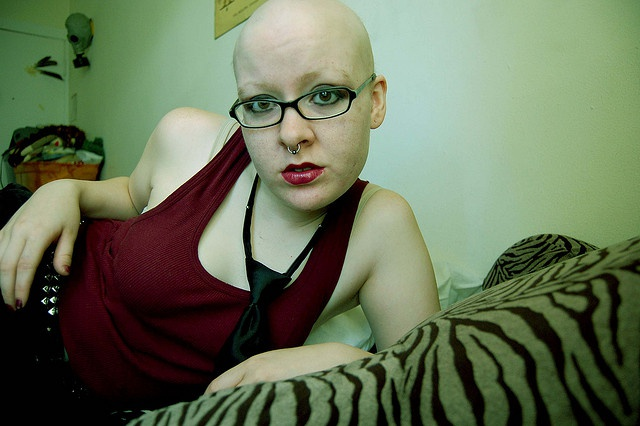Describe the objects in this image and their specific colors. I can see people in darkgreen, black, darkgray, olive, and maroon tones, bed in darkgreen, black, and green tones, and tie in darkgreen, black, darkgray, gray, and olive tones in this image. 